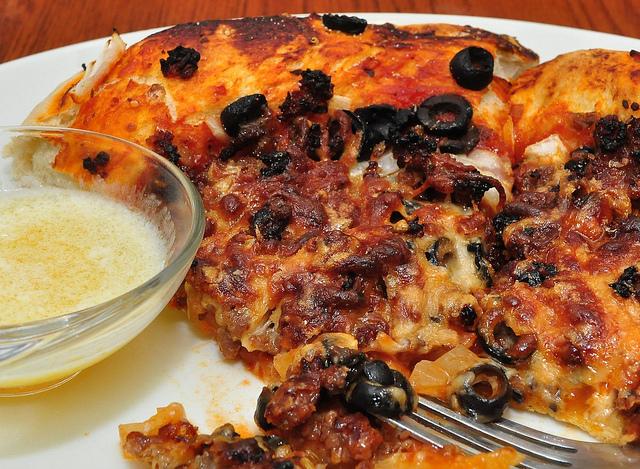How many food is on the bottom plate?
Keep it brief. 1. What snack is this?
Answer briefly. Pizza. Was the pizza tasty?
Keep it brief. Yes. What is the black ingredient on top?
Quick response, please. Olives. Is this meal healthy?
Be succinct. No. What toppings are on the pizza?
Quick response, please. Olives. 